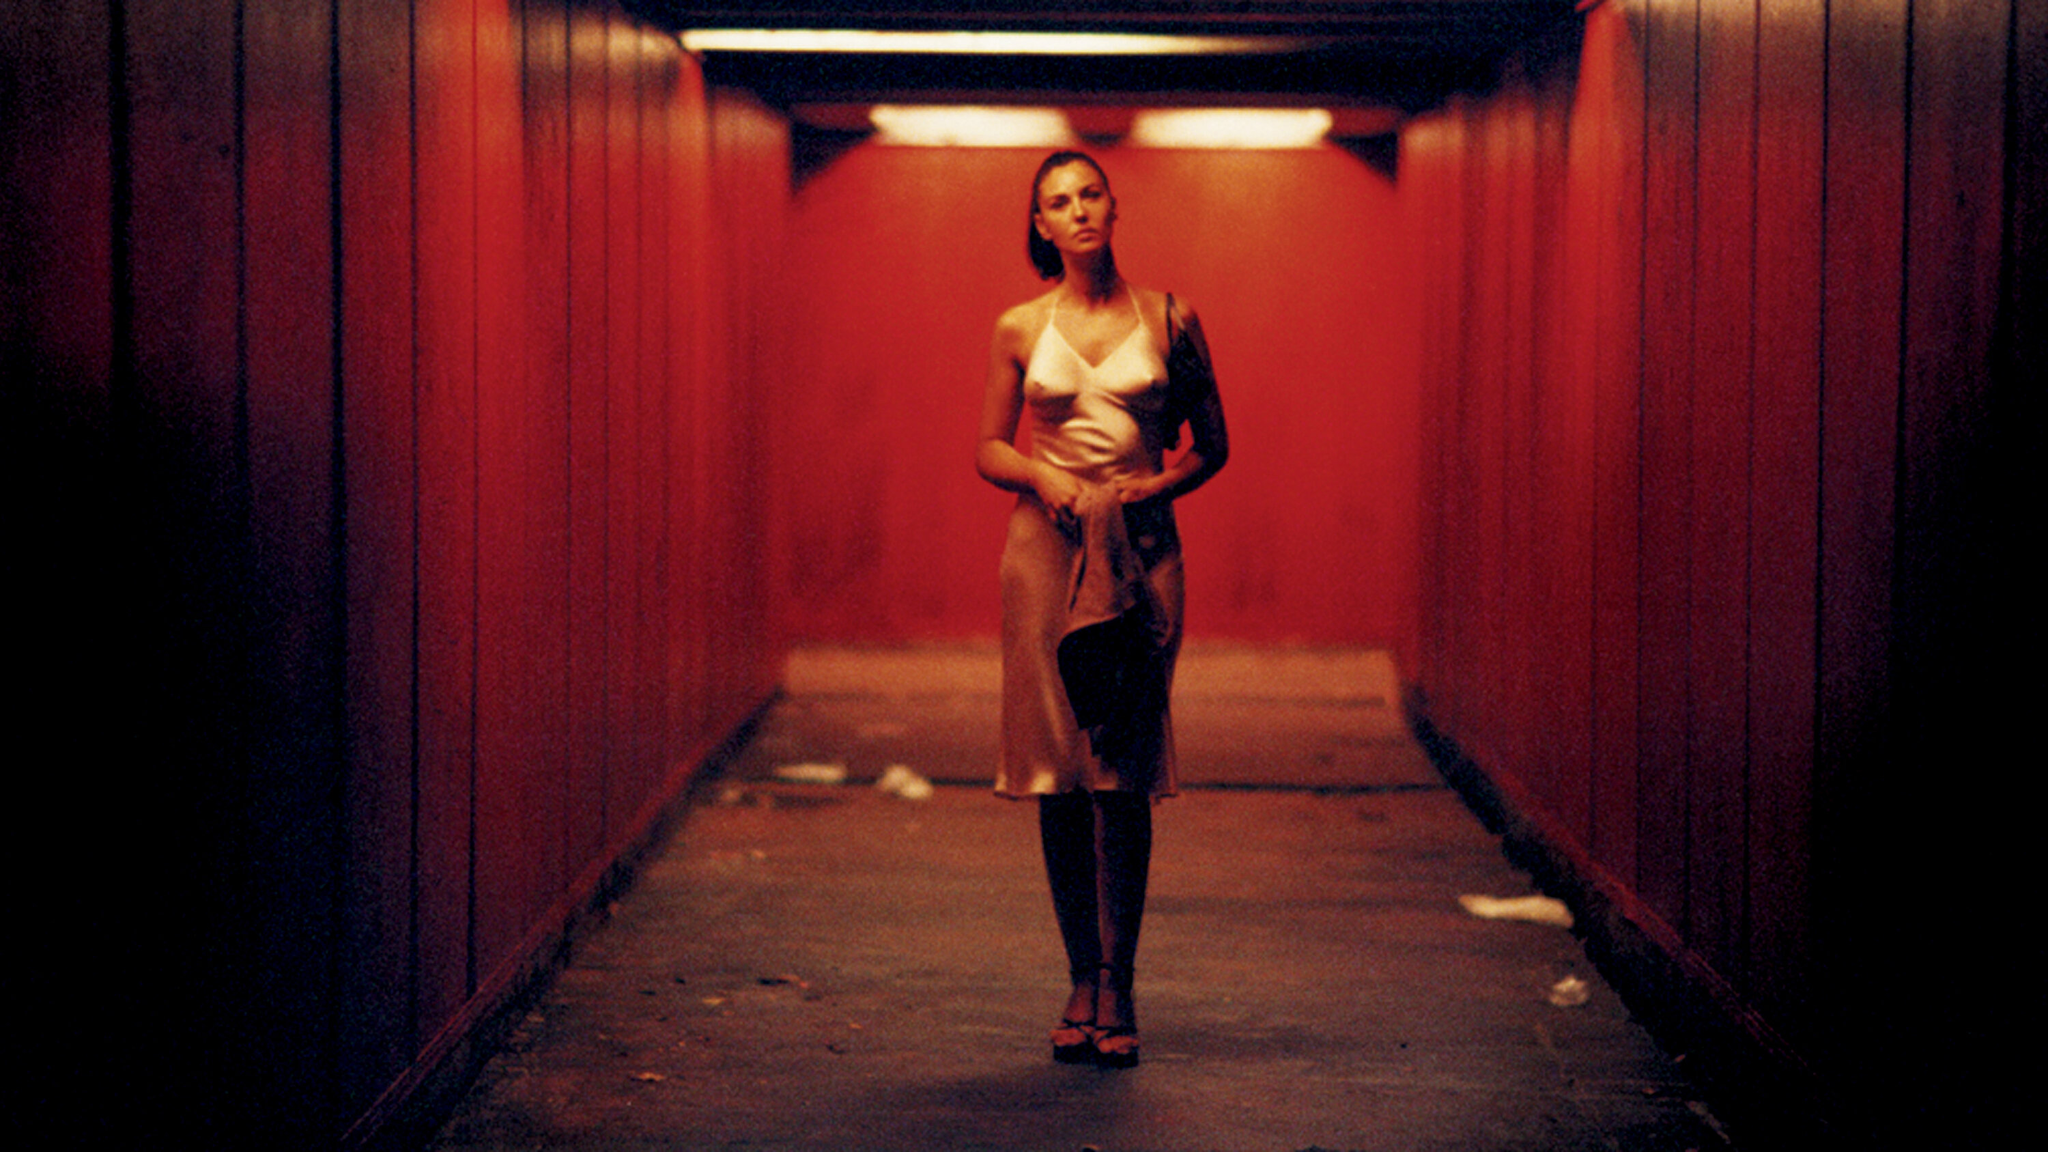What mood does the setting of this image evoke? The setting of the image evokes a mood of isolation and contemplation. The red lighting and the tunnel's confinement create an intense, somewhat melancholic atmosphere, highlighting the subject's solitary presence within the space. 